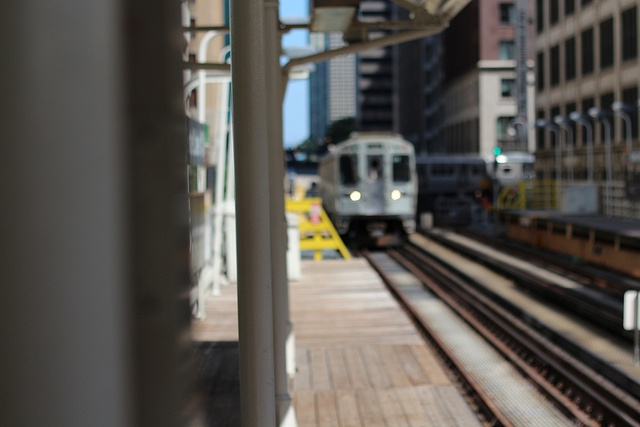Describe the objects in this image and their specific colors. I can see train in black, gray, and darkgray tones and traffic light in black, darkgray, gray, white, and turquoise tones in this image. 